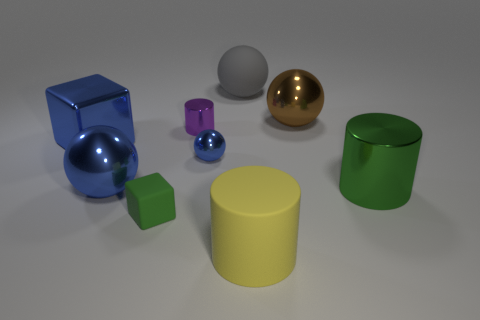Can you describe the colors and shapes of the objects in the foreground? The foreground consists of a blue cube, a golden sphere, and a green cylinder, varied in shapes but rich and vibrant in color. 